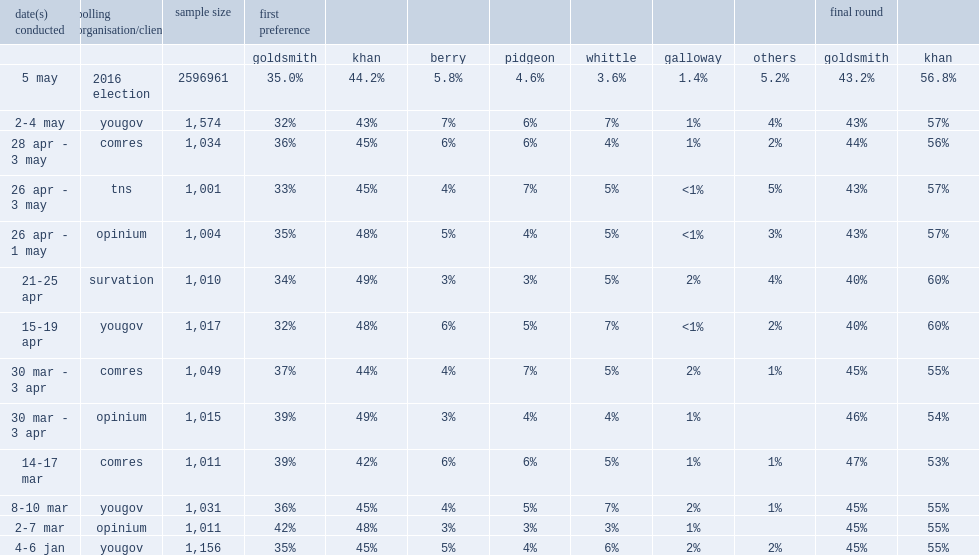What was a total of votes in the 2016 london mayoral election? 2596961. 